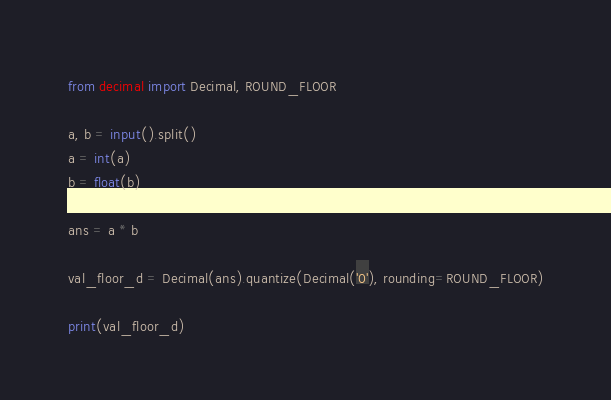<code> <loc_0><loc_0><loc_500><loc_500><_Python_>from decimal import Decimal, ROUND_FLOOR

a, b = input().split()
a = int(a)
b = float(b)

ans = a * b

val_floor_d = Decimal(ans).quantize(Decimal('0'), rounding=ROUND_FLOOR)

print(val_floor_d)</code> 